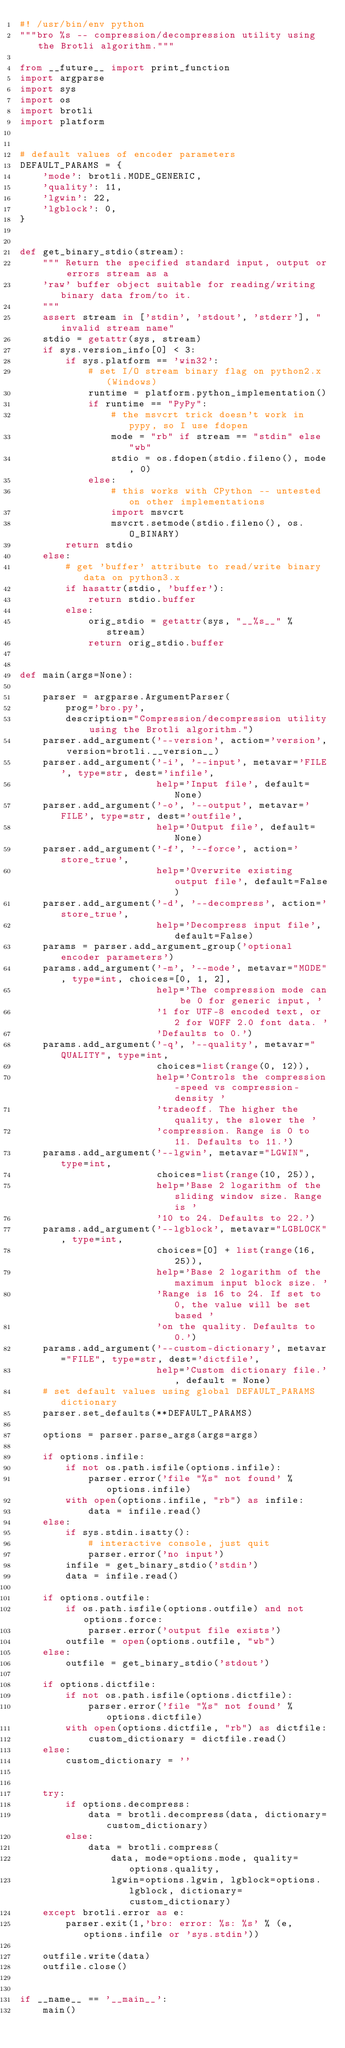Convert code to text. <code><loc_0><loc_0><loc_500><loc_500><_Python_>#! /usr/bin/env python
"""bro %s -- compression/decompression utility using the Brotli algorithm."""

from __future__ import print_function
import argparse
import sys
import os
import brotli
import platform


# default values of encoder parameters
DEFAULT_PARAMS = {
    'mode': brotli.MODE_GENERIC,
    'quality': 11,
    'lgwin': 22,
    'lgblock': 0,
}


def get_binary_stdio(stream):
    """ Return the specified standard input, output or errors stream as a
    'raw' buffer object suitable for reading/writing binary data from/to it.
    """
    assert stream in ['stdin', 'stdout', 'stderr'], "invalid stream name"
    stdio = getattr(sys, stream)
    if sys.version_info[0] < 3:
        if sys.platform == 'win32':
            # set I/O stream binary flag on python2.x (Windows)
            runtime = platform.python_implementation()
            if runtime == "PyPy":
                # the msvcrt trick doesn't work in pypy, so I use fdopen
                mode = "rb" if stream == "stdin" else "wb"
                stdio = os.fdopen(stdio.fileno(), mode, 0)
            else:
                # this works with CPython -- untested on other implementations
                import msvcrt
                msvcrt.setmode(stdio.fileno(), os.O_BINARY)
        return stdio
    else:
        # get 'buffer' attribute to read/write binary data on python3.x
        if hasattr(stdio, 'buffer'):
            return stdio.buffer
        else:
            orig_stdio = getattr(sys, "__%s__" % stream)
            return orig_stdio.buffer


def main(args=None):

    parser = argparse.ArgumentParser(
        prog='bro.py',
        description="Compression/decompression utility using the Brotli algorithm.")
    parser.add_argument('--version', action='version', version=brotli.__version__)
    parser.add_argument('-i', '--input', metavar='FILE', type=str, dest='infile',
                        help='Input file', default=None)
    parser.add_argument('-o', '--output', metavar='FILE', type=str, dest='outfile',
                        help='Output file', default=None)
    parser.add_argument('-f', '--force', action='store_true',
                        help='Overwrite existing output file', default=False)
    parser.add_argument('-d', '--decompress', action='store_true',
                        help='Decompress input file', default=False)
    params = parser.add_argument_group('optional encoder parameters')
    params.add_argument('-m', '--mode', metavar="MODE", type=int, choices=[0, 1, 2],
                        help='The compression mode can be 0 for generic input, '
                        '1 for UTF-8 encoded text, or 2 for WOFF 2.0 font data. '
                        'Defaults to 0.')
    params.add_argument('-q', '--quality', metavar="QUALITY", type=int,
                        choices=list(range(0, 12)),
                        help='Controls the compression-speed vs compression-density '
                        'tradeoff. The higher the quality, the slower the '
                        'compression. Range is 0 to 11. Defaults to 11.')
    params.add_argument('--lgwin', metavar="LGWIN", type=int,
                        choices=list(range(10, 25)),
                        help='Base 2 logarithm of the sliding window size. Range is '
                        '10 to 24. Defaults to 22.')
    params.add_argument('--lgblock', metavar="LGBLOCK", type=int,
                        choices=[0] + list(range(16, 25)),
                        help='Base 2 logarithm of the maximum input block size. '
                        'Range is 16 to 24. If set to 0, the value will be set based '
                        'on the quality. Defaults to 0.')
    params.add_argument('--custom-dictionary', metavar="FILE", type=str, dest='dictfile',
                        help='Custom dictionary file.', default = None)
    # set default values using global DEFAULT_PARAMS dictionary
    parser.set_defaults(**DEFAULT_PARAMS)

    options = parser.parse_args(args=args)

    if options.infile:
        if not os.path.isfile(options.infile):
            parser.error('file "%s" not found' % options.infile)
        with open(options.infile, "rb") as infile:
            data = infile.read()
    else:
        if sys.stdin.isatty():
            # interactive console, just quit
            parser.error('no input')
        infile = get_binary_stdio('stdin')
        data = infile.read()

    if options.outfile:
        if os.path.isfile(options.outfile) and not options.force:
            parser.error('output file exists')
        outfile = open(options.outfile, "wb")
    else:
        outfile = get_binary_stdio('stdout')

    if options.dictfile:
        if not os.path.isfile(options.dictfile):
            parser.error('file "%s" not found' % options.dictfile)
        with open(options.dictfile, "rb") as dictfile:
            custom_dictionary = dictfile.read()
    else:
        custom_dictionary = ''


    try:
        if options.decompress:
            data = brotli.decompress(data, dictionary=custom_dictionary)
        else:
            data = brotli.compress(
                data, mode=options.mode, quality=options.quality,
                lgwin=options.lgwin, lgblock=options.lgblock, dictionary=custom_dictionary)
    except brotli.error as e:
        parser.exit(1,'bro: error: %s: %s' % (e, options.infile or 'sys.stdin'))

    outfile.write(data)
    outfile.close()


if __name__ == '__main__':
    main()
</code> 